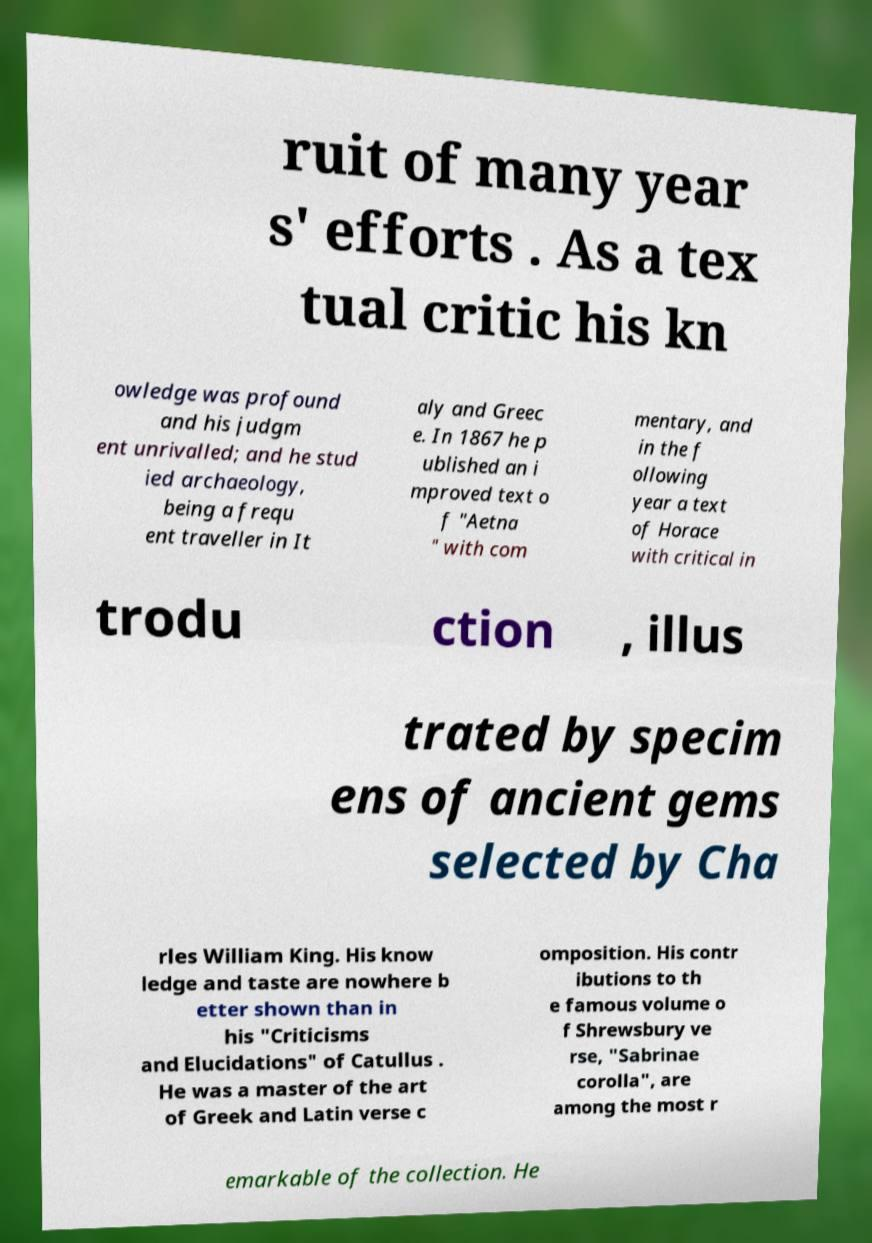Can you read and provide the text displayed in the image?This photo seems to have some interesting text. Can you extract and type it out for me? ruit of many year s' efforts . As a tex tual critic his kn owledge was profound and his judgm ent unrivalled; and he stud ied archaeology, being a frequ ent traveller in It aly and Greec e. In 1867 he p ublished an i mproved text o f "Aetna " with com mentary, and in the f ollowing year a text of Horace with critical in trodu ction , illus trated by specim ens of ancient gems selected by Cha rles William King. His know ledge and taste are nowhere b etter shown than in his "Criticisms and Elucidations" of Catullus . He was a master of the art of Greek and Latin verse c omposition. His contr ibutions to th e famous volume o f Shrewsbury ve rse, "Sabrinae corolla", are among the most r emarkable of the collection. He 